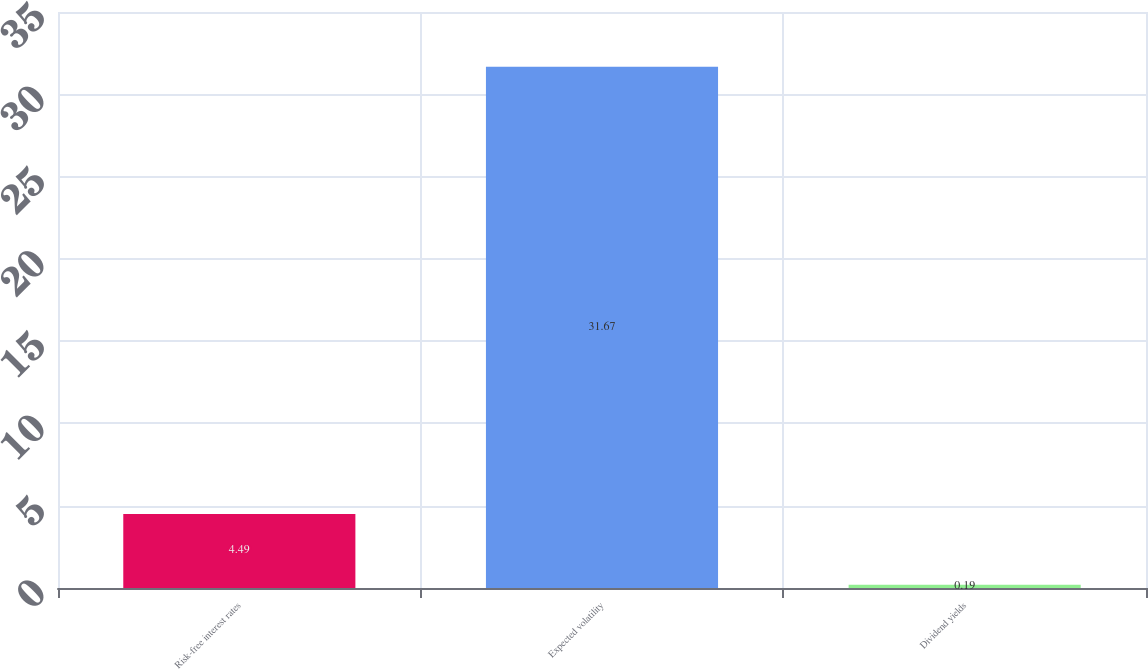Convert chart. <chart><loc_0><loc_0><loc_500><loc_500><bar_chart><fcel>Risk-free interest rates<fcel>Expected volatility<fcel>Dividend yields<nl><fcel>4.49<fcel>31.67<fcel>0.19<nl></chart> 